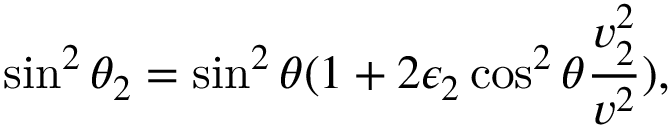<formula> <loc_0><loc_0><loc_500><loc_500>\sin ^ { 2 } \theta _ { 2 } = \sin ^ { 2 } \theta ( 1 + 2 \epsilon _ { 2 } \cos ^ { 2 } \theta { \frac { v _ { 2 } ^ { 2 } } { v ^ { 2 } } } ) ,</formula> 